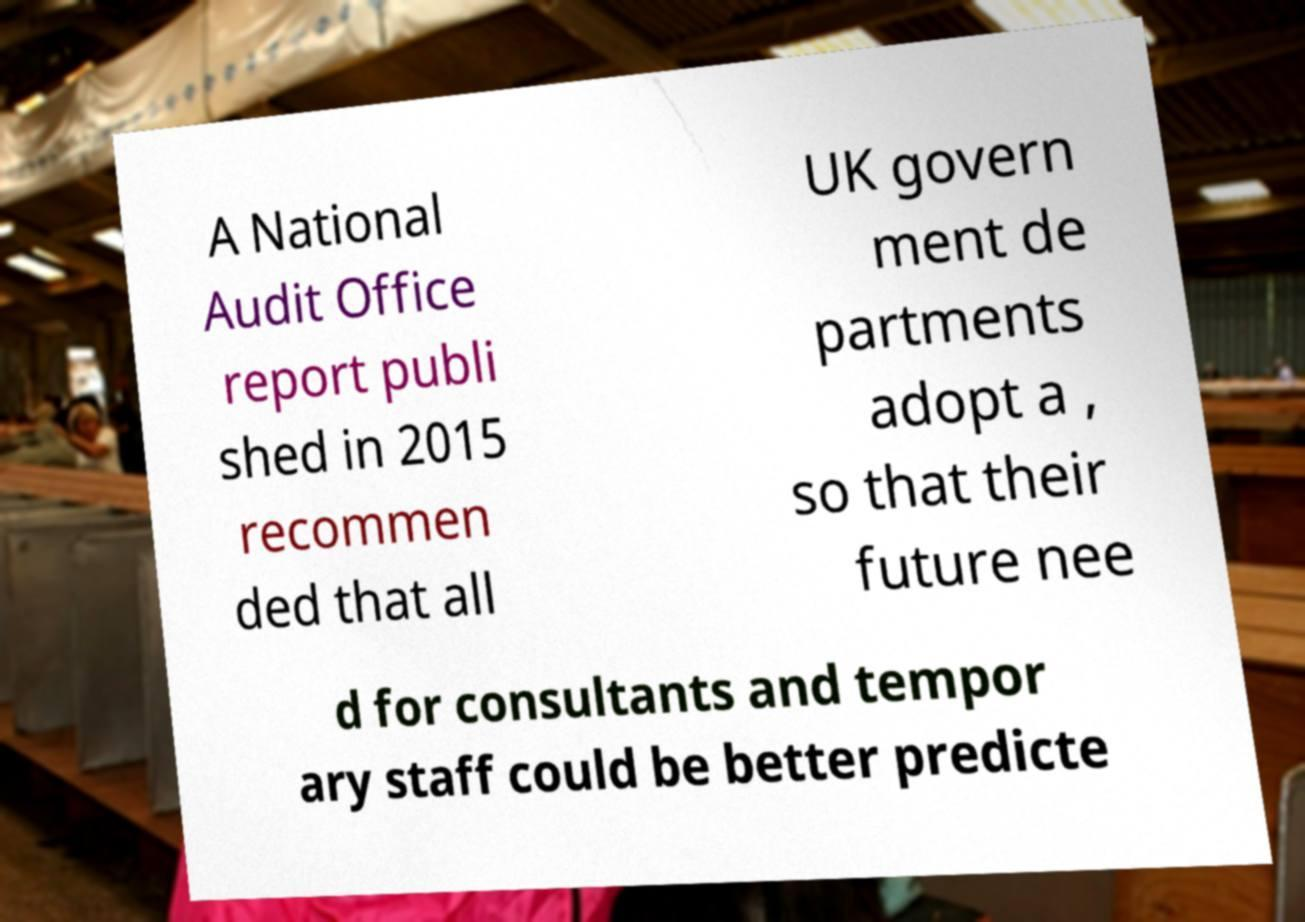For documentation purposes, I need the text within this image transcribed. Could you provide that? A National Audit Office report publi shed in 2015 recommen ded that all UK govern ment de partments adopt a , so that their future nee d for consultants and tempor ary staff could be better predicte 